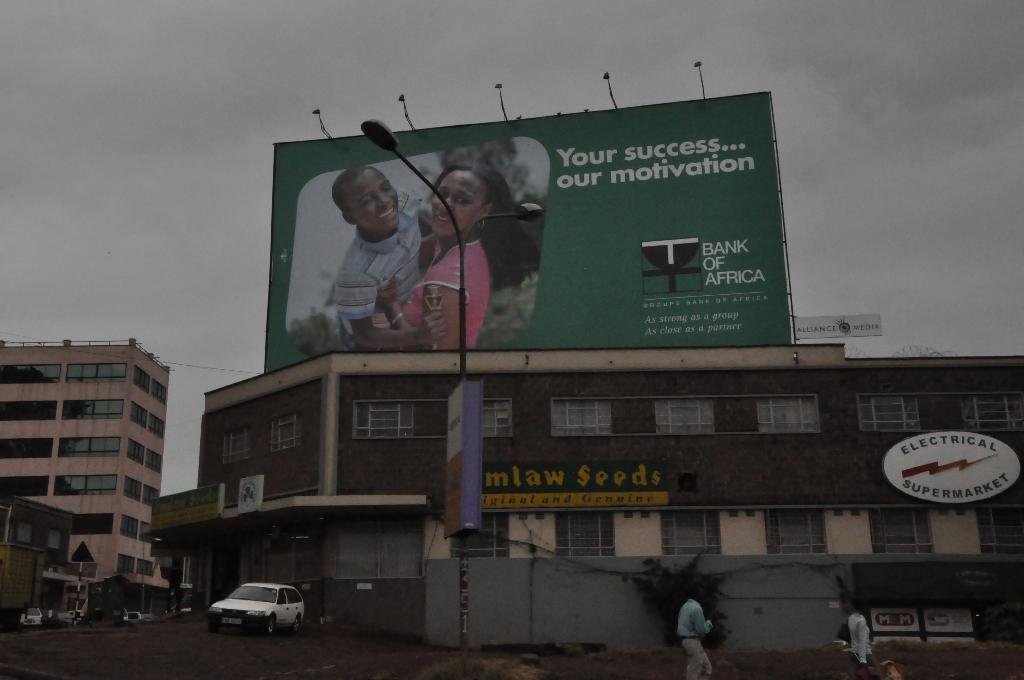<image>
Present a compact description of the photo's key features. An advertisement for Bank of Africa is above a brick building. 